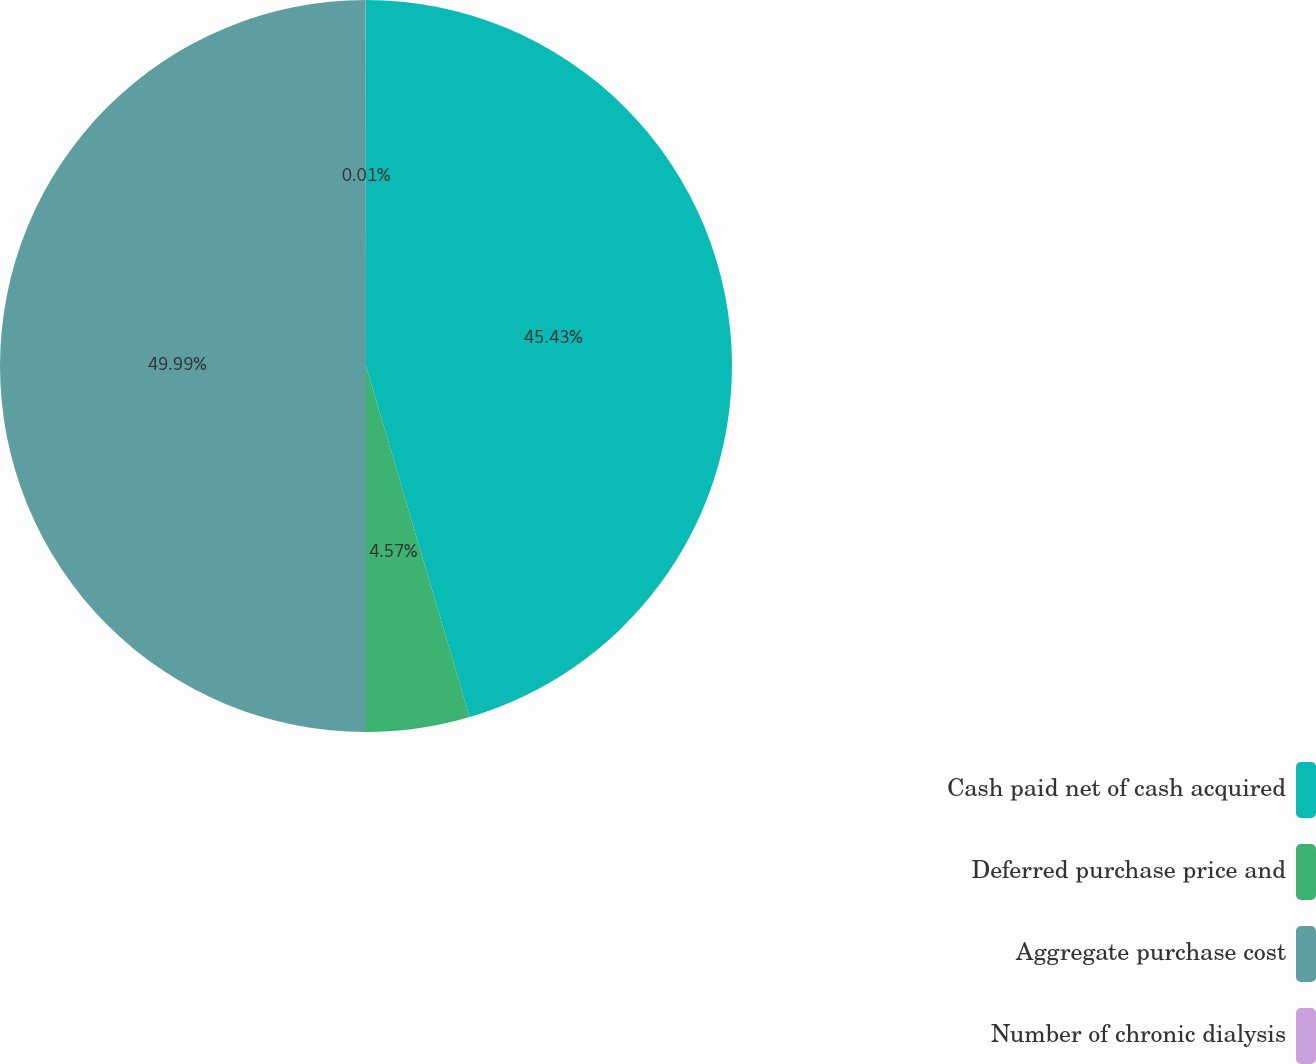<chart> <loc_0><loc_0><loc_500><loc_500><pie_chart><fcel>Cash paid net of cash acquired<fcel>Deferred purchase price and<fcel>Aggregate purchase cost<fcel>Number of chronic dialysis<nl><fcel>45.43%<fcel>4.57%<fcel>49.99%<fcel>0.01%<nl></chart> 